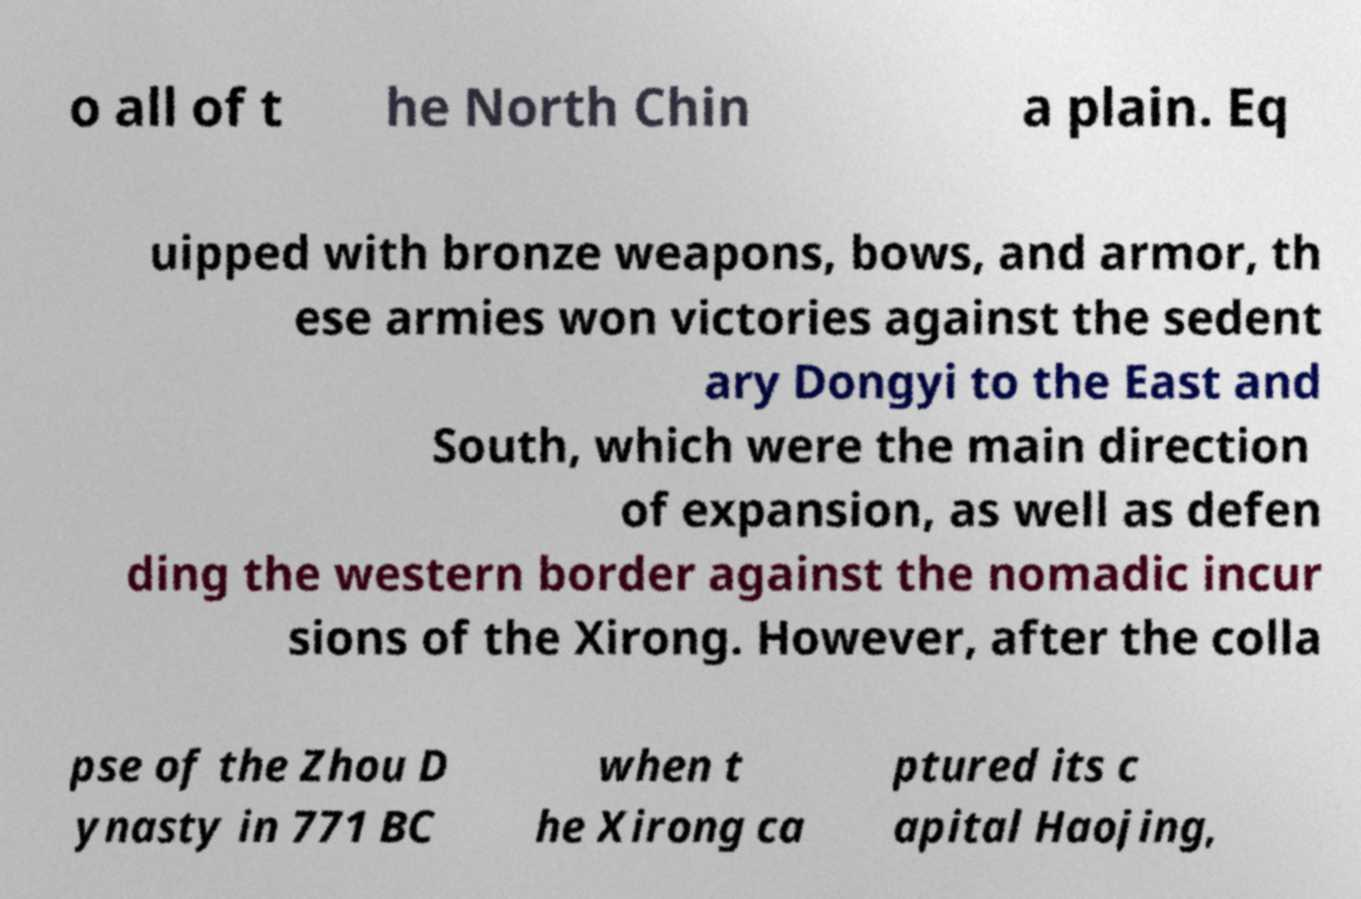For documentation purposes, I need the text within this image transcribed. Could you provide that? o all of t he North Chin a plain. Eq uipped with bronze weapons, bows, and armor, th ese armies won victories against the sedent ary Dongyi to the East and South, which were the main direction of expansion, as well as defen ding the western border against the nomadic incur sions of the Xirong. However, after the colla pse of the Zhou D ynasty in 771 BC when t he Xirong ca ptured its c apital Haojing, 